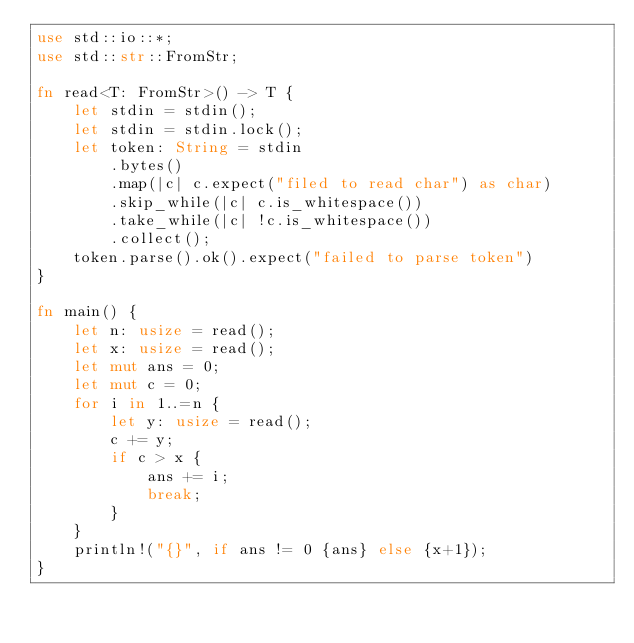Convert code to text. <code><loc_0><loc_0><loc_500><loc_500><_Rust_>use std::io::*;
use std::str::FromStr;

fn read<T: FromStr>() -> T {
    let stdin = stdin();
    let stdin = stdin.lock();
    let token: String = stdin
        .bytes()
        .map(|c| c.expect("filed to read char") as char)
        .skip_while(|c| c.is_whitespace())
        .take_while(|c| !c.is_whitespace())
        .collect();
    token.parse().ok().expect("failed to parse token")
}

fn main() {
    let n: usize = read();
    let x: usize = read();
    let mut ans = 0;
    let mut c = 0;
    for i in 1..=n {
        let y: usize = read();
        c += y;
        if c > x {
            ans += i;
            break;
        }
    }
    println!("{}", if ans != 0 {ans} else {x+1});
}
</code> 